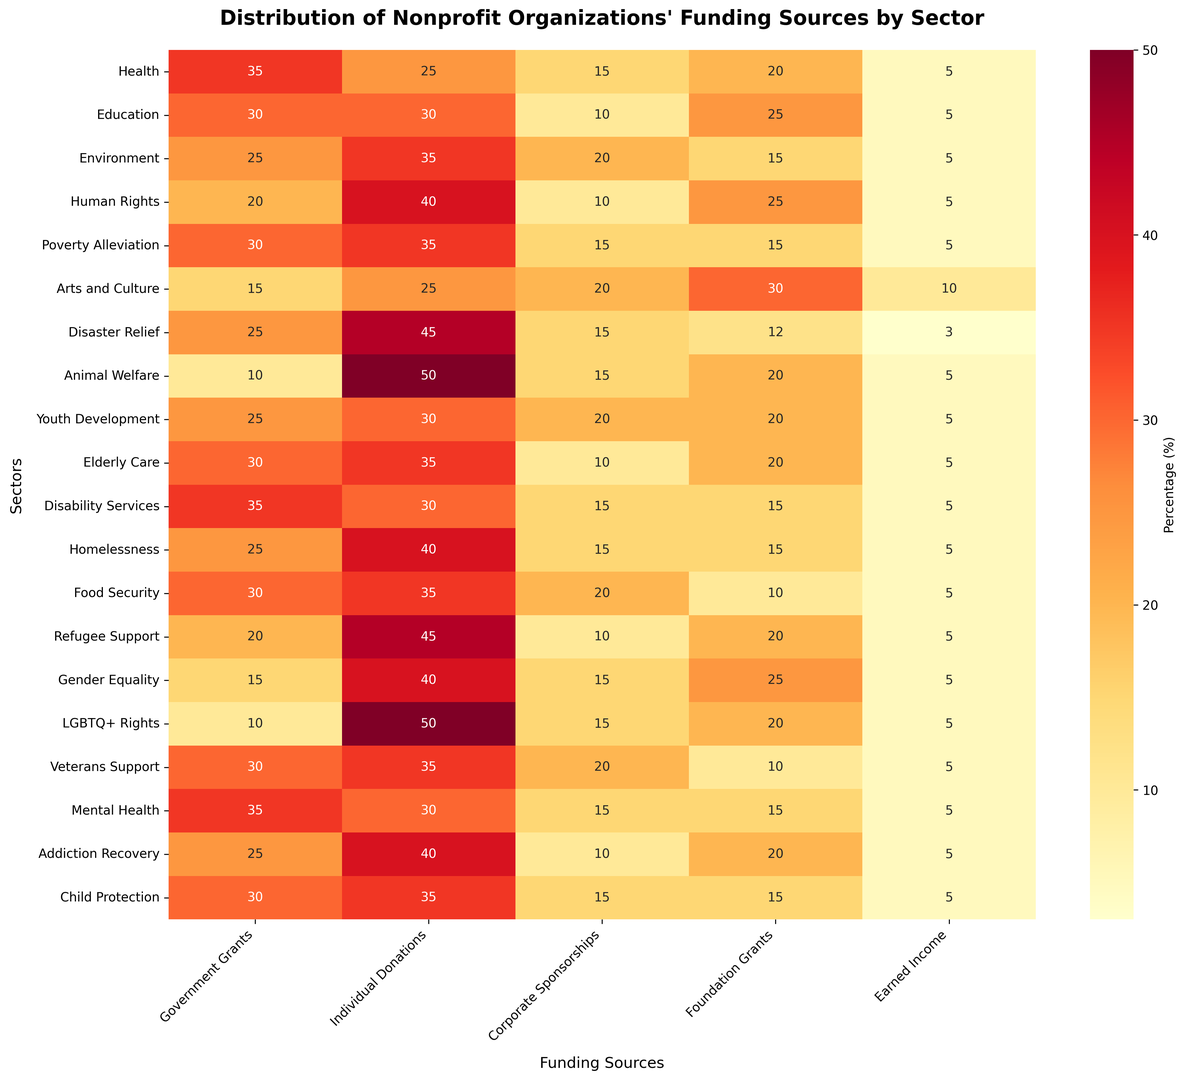Which sector relies most heavily on individual donations? By looking at the column "Individual Donations" in the heatmap and identifying the highest value, we can see that the red color is most intense for the "Animal Welfare" sector.
Answer: Animal Welfare Which funding source contributes least to Arts and Culture? In the Arts and Culture row, we can identify the smallest percentage value, which corresponds to 10% for "Earned Income".
Answer: Earned Income Compare the percentage of Government Grants for Health and Mental Health sectors. Which one receives more? Locate the rows for Health and Mental Health in the Government Grants column and compare the values. The Health sector has 35% while the Mental Health sector also has 35%.
Answer: Equal What is the average percentage of Corporate Sponsorships across all sectors? To find the average, sum the values in the Corporate Sponsorships column (15+10+20+10+15+20+15+15+20+10+15+15+20+10+15+15+20+10+15) and divide by the number of sectors (19). The sum is 285, and dividing by 19 gives approximately 15%.
Answer: 15% Which sector has the closest share of Government Grants and Earned Income? Calculate the difference between Government Grants and Earned Income for each sector and find the smallest difference. For Health, the difference is 35-5=30; for Education, it's 30-5=25, etc. The smallest difference is for the Arts and Culture sector, where it's 15-10=5.
Answer: Arts and Culture Which sector has the highest diversity in funding sources (e.g., the most even spread across different sources)? Identify the sector with the smallest variance among its funding sources. Visually, if the heatmap rows have colors with similar shades, that indicates a more even spread. For example, Education sector shows values 30, 30, 10, 25, 5, which visually indicates even distribution among major sources.
Answer: Education For which two sectors is the proportion of Foundation Grants exactly 25%? Check the Foundation Grants column and identify rows where the value is 25%. The sectors are Education and Human Rights.
Answer: Education, Human Rights What is the combined share of Government Grants and Foundation Grants for Poverty Alleviation? Sum the values in the Poverty Alleviation row for Government Grants (30) and Foundation Grants (15). The combined share is 30 + 15 = 45%.
Answer: 45% Which funding source contributes exactly 5% across all sectors? Scan each column to find a value of 5%. Earned Income consistently shows this 5% value across all sectors.
Answer: Earned Income 